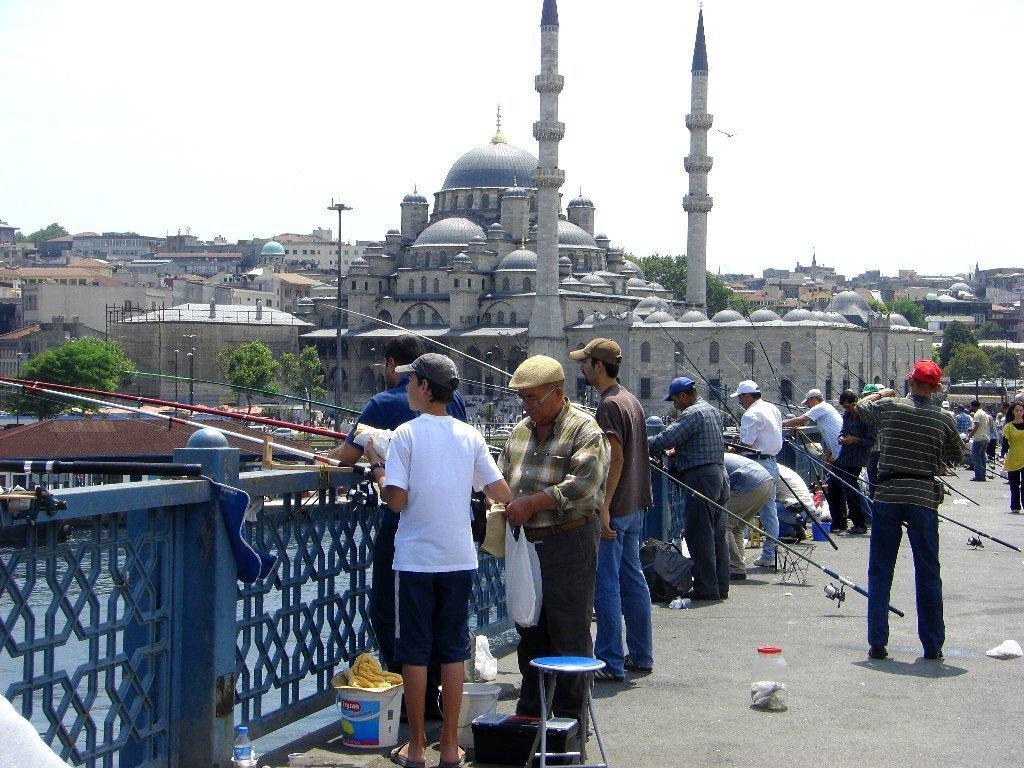In one or two sentences, can you explain what this image depicts? In this image we can see so many people are standing and holding fishing sticks in their hand. Left side of the image blue color fencing is there. Background of the image buildings are present. Top of the image sky is there which is in white color. Bottom of the image table, buckets, bottle and container are there on the road. 